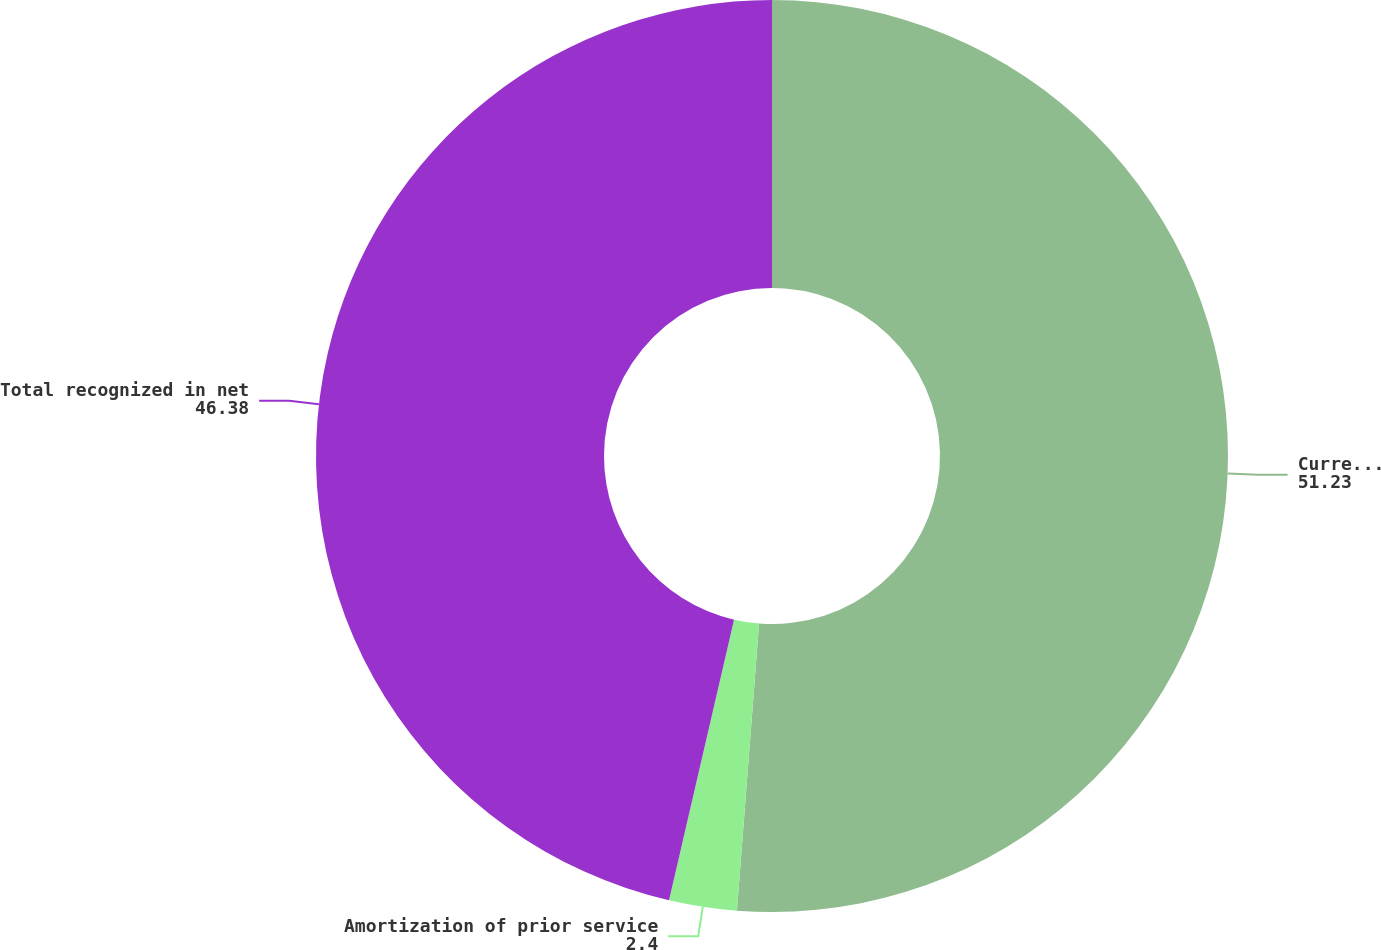Convert chart to OTSL. <chart><loc_0><loc_0><loc_500><loc_500><pie_chart><fcel>Current year actuarial (gain)<fcel>Amortization of prior service<fcel>Total recognized in net<nl><fcel>51.23%<fcel>2.4%<fcel>46.38%<nl></chart> 